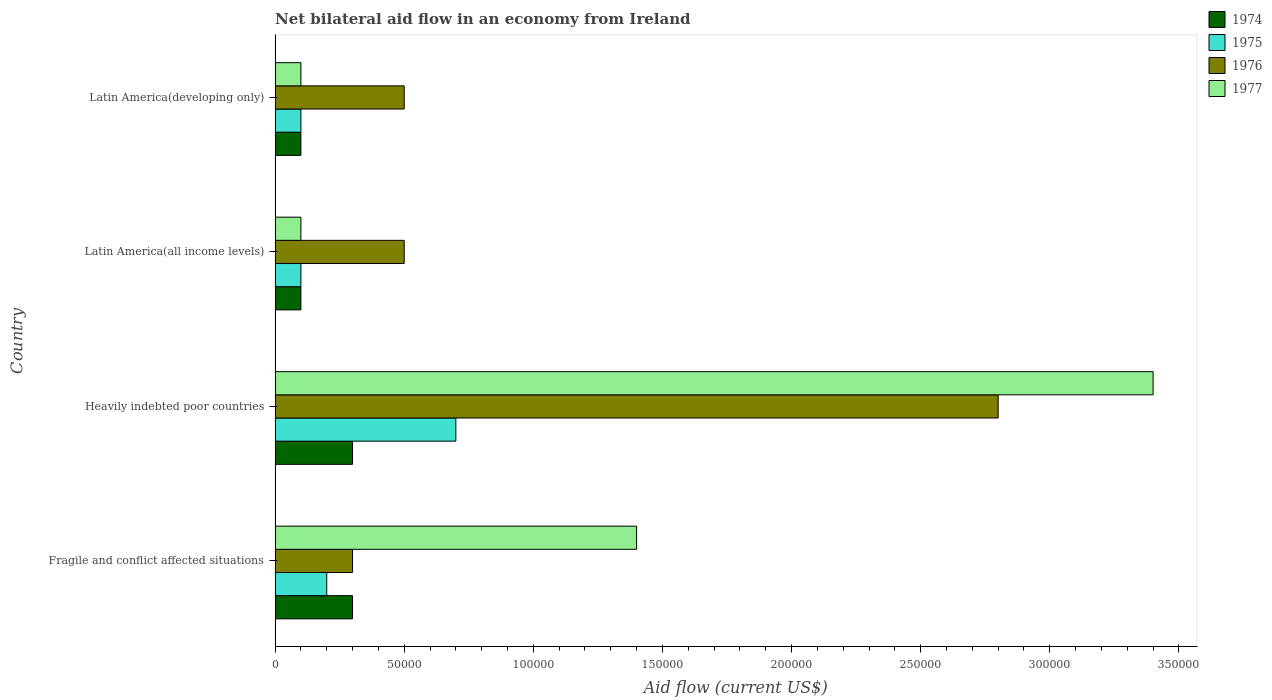How many groups of bars are there?
Your response must be concise. 4. How many bars are there on the 3rd tick from the top?
Offer a terse response. 4. How many bars are there on the 4th tick from the bottom?
Offer a terse response. 4. What is the label of the 2nd group of bars from the top?
Ensure brevity in your answer.  Latin America(all income levels). In which country was the net bilateral aid flow in 1976 maximum?
Your response must be concise. Heavily indebted poor countries. In which country was the net bilateral aid flow in 1975 minimum?
Make the answer very short. Latin America(all income levels). What is the total net bilateral aid flow in 1977 in the graph?
Make the answer very short. 5.00e+05. What is the difference between the net bilateral aid flow in 1975 in Heavily indebted poor countries and the net bilateral aid flow in 1977 in Latin America(all income levels)?
Your answer should be very brief. 6.00e+04. What is the average net bilateral aid flow in 1977 per country?
Provide a succinct answer. 1.25e+05. What is the difference between the net bilateral aid flow in 1977 and net bilateral aid flow in 1976 in Latin America(all income levels)?
Your response must be concise. -4.00e+04. What is the difference between the highest and the lowest net bilateral aid flow in 1976?
Provide a succinct answer. 2.50e+05. In how many countries, is the net bilateral aid flow in 1977 greater than the average net bilateral aid flow in 1977 taken over all countries?
Your response must be concise. 2. Is the sum of the net bilateral aid flow in 1976 in Latin America(all income levels) and Latin America(developing only) greater than the maximum net bilateral aid flow in 1977 across all countries?
Provide a succinct answer. No. What does the 4th bar from the top in Latin America(developing only) represents?
Ensure brevity in your answer.  1974. What does the 1st bar from the bottom in Heavily indebted poor countries represents?
Give a very brief answer. 1974. Is it the case that in every country, the sum of the net bilateral aid flow in 1977 and net bilateral aid flow in 1975 is greater than the net bilateral aid flow in 1976?
Keep it short and to the point. No. How many bars are there?
Keep it short and to the point. 16. How many legend labels are there?
Provide a short and direct response. 4. What is the title of the graph?
Make the answer very short. Net bilateral aid flow in an economy from Ireland. Does "1992" appear as one of the legend labels in the graph?
Offer a very short reply. No. What is the label or title of the X-axis?
Your answer should be very brief. Aid flow (current US$). What is the Aid flow (current US$) of 1974 in Fragile and conflict affected situations?
Provide a succinct answer. 3.00e+04. What is the Aid flow (current US$) in 1975 in Fragile and conflict affected situations?
Make the answer very short. 2.00e+04. What is the Aid flow (current US$) of 1976 in Fragile and conflict affected situations?
Give a very brief answer. 3.00e+04. What is the Aid flow (current US$) in 1977 in Fragile and conflict affected situations?
Provide a succinct answer. 1.40e+05. What is the Aid flow (current US$) of 1974 in Heavily indebted poor countries?
Make the answer very short. 3.00e+04. What is the Aid flow (current US$) in 1975 in Heavily indebted poor countries?
Your response must be concise. 7.00e+04. What is the Aid flow (current US$) in 1976 in Heavily indebted poor countries?
Keep it short and to the point. 2.80e+05. What is the Aid flow (current US$) in 1974 in Latin America(all income levels)?
Offer a terse response. 10000. What is the Aid flow (current US$) of 1975 in Latin America(all income levels)?
Provide a short and direct response. 10000. What is the Aid flow (current US$) in 1977 in Latin America(all income levels)?
Make the answer very short. 10000. What is the Aid flow (current US$) of 1975 in Latin America(developing only)?
Your response must be concise. 10000. What is the Aid flow (current US$) of 1977 in Latin America(developing only)?
Offer a terse response. 10000. Across all countries, what is the maximum Aid flow (current US$) of 1974?
Provide a short and direct response. 3.00e+04. Across all countries, what is the maximum Aid flow (current US$) of 1975?
Your answer should be compact. 7.00e+04. Across all countries, what is the minimum Aid flow (current US$) of 1976?
Keep it short and to the point. 3.00e+04. Across all countries, what is the minimum Aid flow (current US$) in 1977?
Keep it short and to the point. 10000. What is the total Aid flow (current US$) in 1975 in the graph?
Give a very brief answer. 1.10e+05. What is the total Aid flow (current US$) in 1977 in the graph?
Your answer should be very brief. 5.00e+05. What is the difference between the Aid flow (current US$) in 1975 in Fragile and conflict affected situations and that in Heavily indebted poor countries?
Give a very brief answer. -5.00e+04. What is the difference between the Aid flow (current US$) of 1977 in Fragile and conflict affected situations and that in Heavily indebted poor countries?
Give a very brief answer. -2.00e+05. What is the difference between the Aid flow (current US$) in 1974 in Fragile and conflict affected situations and that in Latin America(all income levels)?
Your response must be concise. 2.00e+04. What is the difference between the Aid flow (current US$) in 1976 in Fragile and conflict affected situations and that in Latin America(all income levels)?
Offer a very short reply. -2.00e+04. What is the difference between the Aid flow (current US$) in 1977 in Fragile and conflict affected situations and that in Latin America(all income levels)?
Provide a short and direct response. 1.30e+05. What is the difference between the Aid flow (current US$) of 1974 in Fragile and conflict affected situations and that in Latin America(developing only)?
Offer a very short reply. 2.00e+04. What is the difference between the Aid flow (current US$) of 1977 in Fragile and conflict affected situations and that in Latin America(developing only)?
Offer a terse response. 1.30e+05. What is the difference between the Aid flow (current US$) in 1974 in Heavily indebted poor countries and that in Latin America(all income levels)?
Provide a succinct answer. 2.00e+04. What is the difference between the Aid flow (current US$) in 1975 in Heavily indebted poor countries and that in Latin America(all income levels)?
Your answer should be very brief. 6.00e+04. What is the difference between the Aid flow (current US$) of 1977 in Heavily indebted poor countries and that in Latin America(all income levels)?
Your answer should be very brief. 3.30e+05. What is the difference between the Aid flow (current US$) of 1974 in Heavily indebted poor countries and that in Latin America(developing only)?
Offer a terse response. 2.00e+04. What is the difference between the Aid flow (current US$) in 1974 in Latin America(all income levels) and that in Latin America(developing only)?
Ensure brevity in your answer.  0. What is the difference between the Aid flow (current US$) of 1977 in Latin America(all income levels) and that in Latin America(developing only)?
Your answer should be compact. 0. What is the difference between the Aid flow (current US$) in 1974 in Fragile and conflict affected situations and the Aid flow (current US$) in 1976 in Heavily indebted poor countries?
Your response must be concise. -2.50e+05. What is the difference between the Aid flow (current US$) of 1974 in Fragile and conflict affected situations and the Aid flow (current US$) of 1977 in Heavily indebted poor countries?
Provide a short and direct response. -3.10e+05. What is the difference between the Aid flow (current US$) of 1975 in Fragile and conflict affected situations and the Aid flow (current US$) of 1976 in Heavily indebted poor countries?
Make the answer very short. -2.60e+05. What is the difference between the Aid flow (current US$) in 1975 in Fragile and conflict affected situations and the Aid flow (current US$) in 1977 in Heavily indebted poor countries?
Your response must be concise. -3.20e+05. What is the difference between the Aid flow (current US$) in 1976 in Fragile and conflict affected situations and the Aid flow (current US$) in 1977 in Heavily indebted poor countries?
Keep it short and to the point. -3.10e+05. What is the difference between the Aid flow (current US$) in 1976 in Fragile and conflict affected situations and the Aid flow (current US$) in 1977 in Latin America(all income levels)?
Your response must be concise. 2.00e+04. What is the difference between the Aid flow (current US$) of 1974 in Fragile and conflict affected situations and the Aid flow (current US$) of 1975 in Latin America(developing only)?
Your response must be concise. 2.00e+04. What is the difference between the Aid flow (current US$) in 1974 in Fragile and conflict affected situations and the Aid flow (current US$) in 1976 in Latin America(developing only)?
Make the answer very short. -2.00e+04. What is the difference between the Aid flow (current US$) in 1975 in Fragile and conflict affected situations and the Aid flow (current US$) in 1977 in Latin America(developing only)?
Offer a very short reply. 10000. What is the difference between the Aid flow (current US$) of 1974 in Heavily indebted poor countries and the Aid flow (current US$) of 1975 in Latin America(all income levels)?
Give a very brief answer. 2.00e+04. What is the difference between the Aid flow (current US$) in 1974 in Heavily indebted poor countries and the Aid flow (current US$) in 1976 in Latin America(all income levels)?
Ensure brevity in your answer.  -2.00e+04. What is the difference between the Aid flow (current US$) of 1974 in Heavily indebted poor countries and the Aid flow (current US$) of 1977 in Latin America(all income levels)?
Ensure brevity in your answer.  2.00e+04. What is the difference between the Aid flow (current US$) in 1976 in Heavily indebted poor countries and the Aid flow (current US$) in 1977 in Latin America(all income levels)?
Ensure brevity in your answer.  2.70e+05. What is the difference between the Aid flow (current US$) of 1974 in Heavily indebted poor countries and the Aid flow (current US$) of 1975 in Latin America(developing only)?
Ensure brevity in your answer.  2.00e+04. What is the difference between the Aid flow (current US$) in 1974 in Heavily indebted poor countries and the Aid flow (current US$) in 1977 in Latin America(developing only)?
Make the answer very short. 2.00e+04. What is the difference between the Aid flow (current US$) in 1975 in Heavily indebted poor countries and the Aid flow (current US$) in 1976 in Latin America(developing only)?
Make the answer very short. 2.00e+04. What is the difference between the Aid flow (current US$) of 1975 in Heavily indebted poor countries and the Aid flow (current US$) of 1977 in Latin America(developing only)?
Offer a terse response. 6.00e+04. What is the difference between the Aid flow (current US$) of 1974 in Latin America(all income levels) and the Aid flow (current US$) of 1975 in Latin America(developing only)?
Offer a terse response. 0. What is the difference between the Aid flow (current US$) of 1974 in Latin America(all income levels) and the Aid flow (current US$) of 1976 in Latin America(developing only)?
Make the answer very short. -4.00e+04. What is the difference between the Aid flow (current US$) of 1974 in Latin America(all income levels) and the Aid flow (current US$) of 1977 in Latin America(developing only)?
Provide a succinct answer. 0. What is the difference between the Aid flow (current US$) in 1975 in Latin America(all income levels) and the Aid flow (current US$) in 1976 in Latin America(developing only)?
Your answer should be compact. -4.00e+04. What is the difference between the Aid flow (current US$) in 1975 in Latin America(all income levels) and the Aid flow (current US$) in 1977 in Latin America(developing only)?
Ensure brevity in your answer.  0. What is the average Aid flow (current US$) of 1974 per country?
Give a very brief answer. 2.00e+04. What is the average Aid flow (current US$) in 1975 per country?
Provide a short and direct response. 2.75e+04. What is the average Aid flow (current US$) of 1976 per country?
Make the answer very short. 1.02e+05. What is the average Aid flow (current US$) in 1977 per country?
Your answer should be compact. 1.25e+05. What is the difference between the Aid flow (current US$) of 1974 and Aid flow (current US$) of 1975 in Fragile and conflict affected situations?
Provide a succinct answer. 10000. What is the difference between the Aid flow (current US$) of 1974 and Aid flow (current US$) of 1976 in Fragile and conflict affected situations?
Offer a very short reply. 0. What is the difference between the Aid flow (current US$) in 1974 and Aid flow (current US$) in 1977 in Fragile and conflict affected situations?
Your response must be concise. -1.10e+05. What is the difference between the Aid flow (current US$) of 1975 and Aid flow (current US$) of 1976 in Fragile and conflict affected situations?
Your response must be concise. -10000. What is the difference between the Aid flow (current US$) of 1975 and Aid flow (current US$) of 1977 in Fragile and conflict affected situations?
Ensure brevity in your answer.  -1.20e+05. What is the difference between the Aid flow (current US$) of 1976 and Aid flow (current US$) of 1977 in Fragile and conflict affected situations?
Offer a very short reply. -1.10e+05. What is the difference between the Aid flow (current US$) in 1974 and Aid flow (current US$) in 1976 in Heavily indebted poor countries?
Provide a succinct answer. -2.50e+05. What is the difference between the Aid flow (current US$) of 1974 and Aid flow (current US$) of 1977 in Heavily indebted poor countries?
Provide a succinct answer. -3.10e+05. What is the difference between the Aid flow (current US$) of 1975 and Aid flow (current US$) of 1976 in Heavily indebted poor countries?
Provide a succinct answer. -2.10e+05. What is the difference between the Aid flow (current US$) of 1975 and Aid flow (current US$) of 1977 in Heavily indebted poor countries?
Ensure brevity in your answer.  -2.70e+05. What is the difference between the Aid flow (current US$) of 1976 and Aid flow (current US$) of 1977 in Heavily indebted poor countries?
Your answer should be very brief. -6.00e+04. What is the difference between the Aid flow (current US$) in 1974 and Aid flow (current US$) in 1975 in Latin America(all income levels)?
Your response must be concise. 0. What is the difference between the Aid flow (current US$) in 1975 and Aid flow (current US$) in 1976 in Latin America(all income levels)?
Give a very brief answer. -4.00e+04. What is the difference between the Aid flow (current US$) of 1975 and Aid flow (current US$) of 1977 in Latin America(all income levels)?
Ensure brevity in your answer.  0. What is the difference between the Aid flow (current US$) in 1976 and Aid flow (current US$) in 1977 in Latin America(all income levels)?
Your answer should be very brief. 4.00e+04. What is the difference between the Aid flow (current US$) of 1974 and Aid flow (current US$) of 1975 in Latin America(developing only)?
Your answer should be very brief. 0. What is the ratio of the Aid flow (current US$) of 1975 in Fragile and conflict affected situations to that in Heavily indebted poor countries?
Offer a terse response. 0.29. What is the ratio of the Aid flow (current US$) of 1976 in Fragile and conflict affected situations to that in Heavily indebted poor countries?
Offer a terse response. 0.11. What is the ratio of the Aid flow (current US$) in 1977 in Fragile and conflict affected situations to that in Heavily indebted poor countries?
Provide a short and direct response. 0.41. What is the ratio of the Aid flow (current US$) in 1974 in Fragile and conflict affected situations to that in Latin America(all income levels)?
Your answer should be very brief. 3. What is the ratio of the Aid flow (current US$) in 1977 in Fragile and conflict affected situations to that in Latin America(all income levels)?
Ensure brevity in your answer.  14. What is the ratio of the Aid flow (current US$) in 1974 in Fragile and conflict affected situations to that in Latin America(developing only)?
Your answer should be very brief. 3. What is the ratio of the Aid flow (current US$) of 1976 in Fragile and conflict affected situations to that in Latin America(developing only)?
Your response must be concise. 0.6. What is the ratio of the Aid flow (current US$) in 1977 in Fragile and conflict affected situations to that in Latin America(developing only)?
Provide a short and direct response. 14. What is the ratio of the Aid flow (current US$) in 1975 in Heavily indebted poor countries to that in Latin America(all income levels)?
Provide a short and direct response. 7. What is the ratio of the Aid flow (current US$) in 1976 in Heavily indebted poor countries to that in Latin America(all income levels)?
Your answer should be compact. 5.6. What is the ratio of the Aid flow (current US$) in 1974 in Heavily indebted poor countries to that in Latin America(developing only)?
Offer a terse response. 3. What is the ratio of the Aid flow (current US$) in 1975 in Heavily indebted poor countries to that in Latin America(developing only)?
Ensure brevity in your answer.  7. What is the ratio of the Aid flow (current US$) in 1976 in Heavily indebted poor countries to that in Latin America(developing only)?
Make the answer very short. 5.6. What is the ratio of the Aid flow (current US$) in 1974 in Latin America(all income levels) to that in Latin America(developing only)?
Provide a succinct answer. 1. What is the ratio of the Aid flow (current US$) of 1975 in Latin America(all income levels) to that in Latin America(developing only)?
Your response must be concise. 1. What is the ratio of the Aid flow (current US$) in 1976 in Latin America(all income levels) to that in Latin America(developing only)?
Keep it short and to the point. 1. What is the difference between the highest and the lowest Aid flow (current US$) in 1974?
Keep it short and to the point. 2.00e+04. 